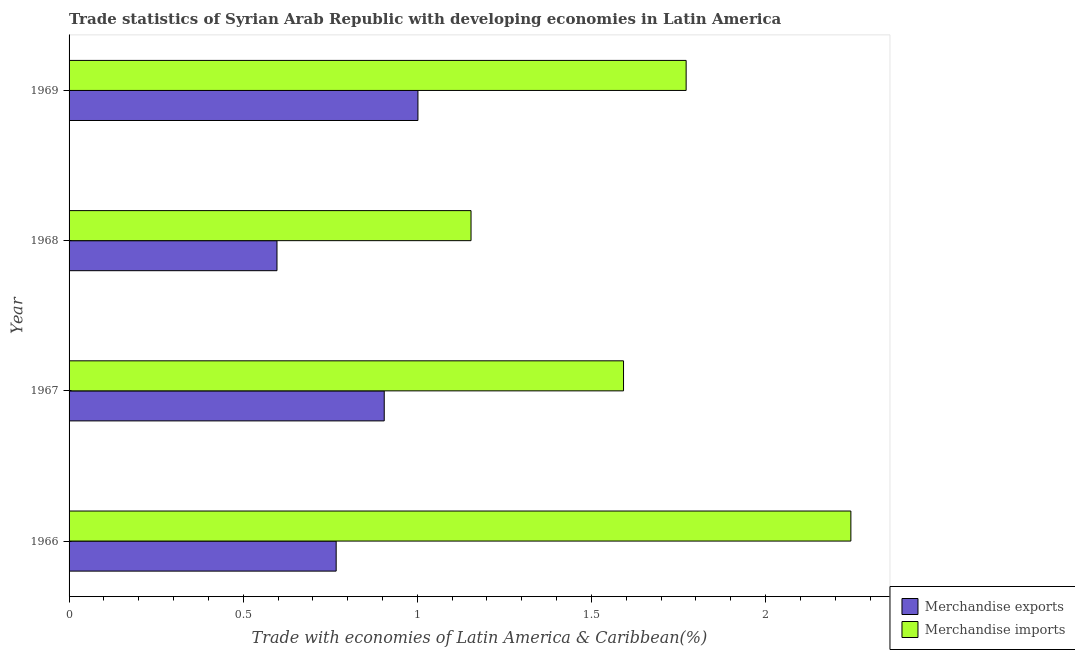How many groups of bars are there?
Provide a short and direct response. 4. Are the number of bars per tick equal to the number of legend labels?
Your answer should be very brief. Yes. How many bars are there on the 2nd tick from the bottom?
Give a very brief answer. 2. What is the label of the 2nd group of bars from the top?
Offer a very short reply. 1968. What is the merchandise imports in 1968?
Your answer should be compact. 1.15. Across all years, what is the maximum merchandise exports?
Make the answer very short. 1. Across all years, what is the minimum merchandise imports?
Give a very brief answer. 1.15. In which year was the merchandise exports maximum?
Ensure brevity in your answer.  1969. In which year was the merchandise exports minimum?
Offer a very short reply. 1968. What is the total merchandise exports in the graph?
Offer a terse response. 3.27. What is the difference between the merchandise exports in 1968 and that in 1969?
Your response must be concise. -0.41. What is the difference between the merchandise imports in 1966 and the merchandise exports in 1969?
Make the answer very short. 1.24. What is the average merchandise imports per year?
Your answer should be compact. 1.69. In the year 1967, what is the difference between the merchandise exports and merchandise imports?
Make the answer very short. -0.69. What is the ratio of the merchandise imports in 1966 to that in 1969?
Make the answer very short. 1.27. What is the difference between the highest and the second highest merchandise exports?
Offer a terse response. 0.1. What is the difference between the highest and the lowest merchandise imports?
Make the answer very short. 1.09. What does the 2nd bar from the top in 1969 represents?
Your response must be concise. Merchandise exports. Are the values on the major ticks of X-axis written in scientific E-notation?
Your answer should be compact. No. Does the graph contain any zero values?
Provide a succinct answer. No. How are the legend labels stacked?
Offer a very short reply. Vertical. What is the title of the graph?
Your response must be concise. Trade statistics of Syrian Arab Republic with developing economies in Latin America. What is the label or title of the X-axis?
Offer a terse response. Trade with economies of Latin America & Caribbean(%). What is the label or title of the Y-axis?
Your answer should be very brief. Year. What is the Trade with economies of Latin America & Caribbean(%) in Merchandise exports in 1966?
Your answer should be compact. 0.77. What is the Trade with economies of Latin America & Caribbean(%) of Merchandise imports in 1966?
Offer a very short reply. 2.24. What is the Trade with economies of Latin America & Caribbean(%) in Merchandise exports in 1967?
Your response must be concise. 0.9. What is the Trade with economies of Latin America & Caribbean(%) of Merchandise imports in 1967?
Make the answer very short. 1.59. What is the Trade with economies of Latin America & Caribbean(%) in Merchandise exports in 1968?
Offer a very short reply. 0.6. What is the Trade with economies of Latin America & Caribbean(%) of Merchandise imports in 1968?
Your response must be concise. 1.15. What is the Trade with economies of Latin America & Caribbean(%) in Merchandise exports in 1969?
Your response must be concise. 1. What is the Trade with economies of Latin America & Caribbean(%) of Merchandise imports in 1969?
Give a very brief answer. 1.77. Across all years, what is the maximum Trade with economies of Latin America & Caribbean(%) of Merchandise exports?
Offer a very short reply. 1. Across all years, what is the maximum Trade with economies of Latin America & Caribbean(%) of Merchandise imports?
Provide a short and direct response. 2.24. Across all years, what is the minimum Trade with economies of Latin America & Caribbean(%) in Merchandise exports?
Your answer should be very brief. 0.6. Across all years, what is the minimum Trade with economies of Latin America & Caribbean(%) in Merchandise imports?
Ensure brevity in your answer.  1.15. What is the total Trade with economies of Latin America & Caribbean(%) in Merchandise exports in the graph?
Your response must be concise. 3.27. What is the total Trade with economies of Latin America & Caribbean(%) of Merchandise imports in the graph?
Your answer should be very brief. 6.76. What is the difference between the Trade with economies of Latin America & Caribbean(%) in Merchandise exports in 1966 and that in 1967?
Provide a succinct answer. -0.14. What is the difference between the Trade with economies of Latin America & Caribbean(%) in Merchandise imports in 1966 and that in 1967?
Provide a short and direct response. 0.65. What is the difference between the Trade with economies of Latin America & Caribbean(%) in Merchandise exports in 1966 and that in 1968?
Your answer should be compact. 0.17. What is the difference between the Trade with economies of Latin America & Caribbean(%) of Merchandise imports in 1966 and that in 1968?
Offer a terse response. 1.09. What is the difference between the Trade with economies of Latin America & Caribbean(%) of Merchandise exports in 1966 and that in 1969?
Ensure brevity in your answer.  -0.23. What is the difference between the Trade with economies of Latin America & Caribbean(%) of Merchandise imports in 1966 and that in 1969?
Provide a short and direct response. 0.47. What is the difference between the Trade with economies of Latin America & Caribbean(%) of Merchandise exports in 1967 and that in 1968?
Your response must be concise. 0.31. What is the difference between the Trade with economies of Latin America & Caribbean(%) of Merchandise imports in 1967 and that in 1968?
Ensure brevity in your answer.  0.44. What is the difference between the Trade with economies of Latin America & Caribbean(%) of Merchandise exports in 1967 and that in 1969?
Keep it short and to the point. -0.1. What is the difference between the Trade with economies of Latin America & Caribbean(%) in Merchandise imports in 1967 and that in 1969?
Keep it short and to the point. -0.18. What is the difference between the Trade with economies of Latin America & Caribbean(%) in Merchandise exports in 1968 and that in 1969?
Provide a succinct answer. -0.4. What is the difference between the Trade with economies of Latin America & Caribbean(%) in Merchandise imports in 1968 and that in 1969?
Provide a succinct answer. -0.62. What is the difference between the Trade with economies of Latin America & Caribbean(%) in Merchandise exports in 1966 and the Trade with economies of Latin America & Caribbean(%) in Merchandise imports in 1967?
Your answer should be compact. -0.83. What is the difference between the Trade with economies of Latin America & Caribbean(%) in Merchandise exports in 1966 and the Trade with economies of Latin America & Caribbean(%) in Merchandise imports in 1968?
Offer a very short reply. -0.39. What is the difference between the Trade with economies of Latin America & Caribbean(%) of Merchandise exports in 1966 and the Trade with economies of Latin America & Caribbean(%) of Merchandise imports in 1969?
Provide a short and direct response. -1. What is the difference between the Trade with economies of Latin America & Caribbean(%) of Merchandise exports in 1967 and the Trade with economies of Latin America & Caribbean(%) of Merchandise imports in 1968?
Your answer should be very brief. -0.25. What is the difference between the Trade with economies of Latin America & Caribbean(%) of Merchandise exports in 1967 and the Trade with economies of Latin America & Caribbean(%) of Merchandise imports in 1969?
Make the answer very short. -0.87. What is the difference between the Trade with economies of Latin America & Caribbean(%) of Merchandise exports in 1968 and the Trade with economies of Latin America & Caribbean(%) of Merchandise imports in 1969?
Ensure brevity in your answer.  -1.17. What is the average Trade with economies of Latin America & Caribbean(%) of Merchandise exports per year?
Keep it short and to the point. 0.82. What is the average Trade with economies of Latin America & Caribbean(%) in Merchandise imports per year?
Make the answer very short. 1.69. In the year 1966, what is the difference between the Trade with economies of Latin America & Caribbean(%) in Merchandise exports and Trade with economies of Latin America & Caribbean(%) in Merchandise imports?
Keep it short and to the point. -1.48. In the year 1967, what is the difference between the Trade with economies of Latin America & Caribbean(%) of Merchandise exports and Trade with economies of Latin America & Caribbean(%) of Merchandise imports?
Your answer should be very brief. -0.69. In the year 1968, what is the difference between the Trade with economies of Latin America & Caribbean(%) in Merchandise exports and Trade with economies of Latin America & Caribbean(%) in Merchandise imports?
Your answer should be very brief. -0.56. In the year 1969, what is the difference between the Trade with economies of Latin America & Caribbean(%) in Merchandise exports and Trade with economies of Latin America & Caribbean(%) in Merchandise imports?
Your answer should be very brief. -0.77. What is the ratio of the Trade with economies of Latin America & Caribbean(%) in Merchandise exports in 1966 to that in 1967?
Offer a very short reply. 0.85. What is the ratio of the Trade with economies of Latin America & Caribbean(%) of Merchandise imports in 1966 to that in 1967?
Keep it short and to the point. 1.41. What is the ratio of the Trade with economies of Latin America & Caribbean(%) of Merchandise exports in 1966 to that in 1968?
Provide a short and direct response. 1.28. What is the ratio of the Trade with economies of Latin America & Caribbean(%) in Merchandise imports in 1966 to that in 1968?
Provide a short and direct response. 1.95. What is the ratio of the Trade with economies of Latin America & Caribbean(%) in Merchandise exports in 1966 to that in 1969?
Give a very brief answer. 0.77. What is the ratio of the Trade with economies of Latin America & Caribbean(%) in Merchandise imports in 1966 to that in 1969?
Offer a very short reply. 1.27. What is the ratio of the Trade with economies of Latin America & Caribbean(%) of Merchandise exports in 1967 to that in 1968?
Give a very brief answer. 1.52. What is the ratio of the Trade with economies of Latin America & Caribbean(%) in Merchandise imports in 1967 to that in 1968?
Your answer should be very brief. 1.38. What is the ratio of the Trade with economies of Latin America & Caribbean(%) in Merchandise exports in 1967 to that in 1969?
Provide a succinct answer. 0.9. What is the ratio of the Trade with economies of Latin America & Caribbean(%) of Merchandise imports in 1967 to that in 1969?
Your answer should be compact. 0.9. What is the ratio of the Trade with economies of Latin America & Caribbean(%) of Merchandise exports in 1968 to that in 1969?
Offer a very short reply. 0.6. What is the ratio of the Trade with economies of Latin America & Caribbean(%) in Merchandise imports in 1968 to that in 1969?
Provide a short and direct response. 0.65. What is the difference between the highest and the second highest Trade with economies of Latin America & Caribbean(%) in Merchandise exports?
Offer a terse response. 0.1. What is the difference between the highest and the second highest Trade with economies of Latin America & Caribbean(%) of Merchandise imports?
Give a very brief answer. 0.47. What is the difference between the highest and the lowest Trade with economies of Latin America & Caribbean(%) in Merchandise exports?
Provide a short and direct response. 0.4. What is the difference between the highest and the lowest Trade with economies of Latin America & Caribbean(%) of Merchandise imports?
Provide a short and direct response. 1.09. 